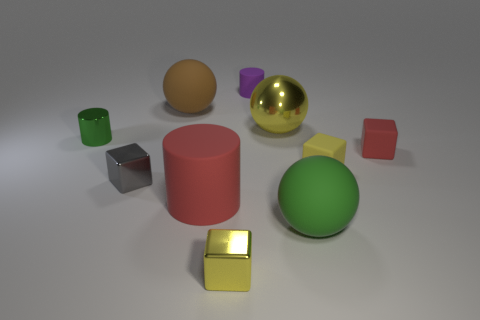Subtract all red cubes. How many cubes are left? 3 Subtract all gray cubes. How many cubes are left? 3 Subtract all purple blocks. Subtract all gray spheres. How many blocks are left? 4 Subtract all balls. How many objects are left? 7 Add 5 red cylinders. How many red cylinders are left? 6 Add 6 large purple rubber blocks. How many large purple rubber blocks exist? 6 Subtract 1 green spheres. How many objects are left? 9 Subtract all large brown objects. Subtract all green cylinders. How many objects are left? 8 